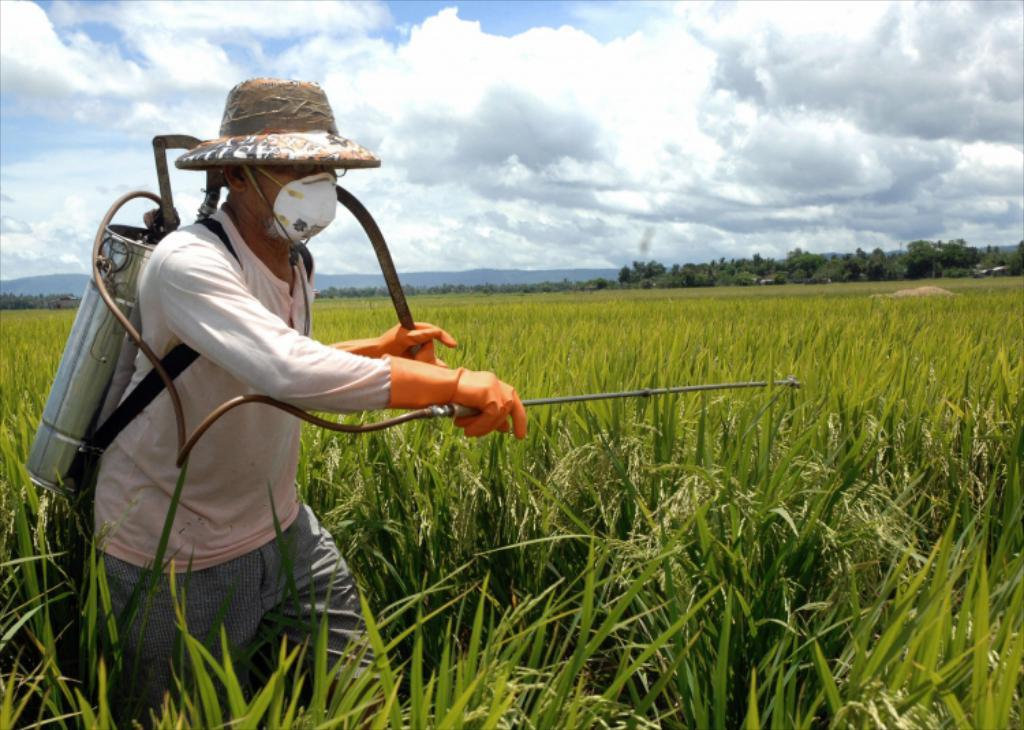What is the person in the image doing? The person is using an agriculture spray machine. What type of environment is depicted in the image? There is grass, plants, and trees in the image, suggesting a natural or agricultural setting. What can be seen in the background of the image? The sky is visible in the background of the image. Can you see a kite flying in the sky in the image? There is no kite visible in the sky in the image. What type of grain is being sprayed by the person using the agriculture spray machine? The image does not specify the type of substance being sprayed by the agriculture spray machine, nor does it mention any grain. 